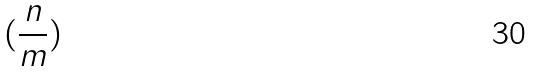<formula> <loc_0><loc_0><loc_500><loc_500>( \frac { n } { m } )</formula> 